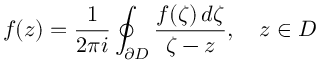<formula> <loc_0><loc_0><loc_500><loc_500>f ( z ) = { \frac { 1 } { 2 \pi i } } \oint _ { \partial D } { \frac { f ( \zeta ) \, d \zeta } { \zeta - z } } , \quad z \in D</formula> 